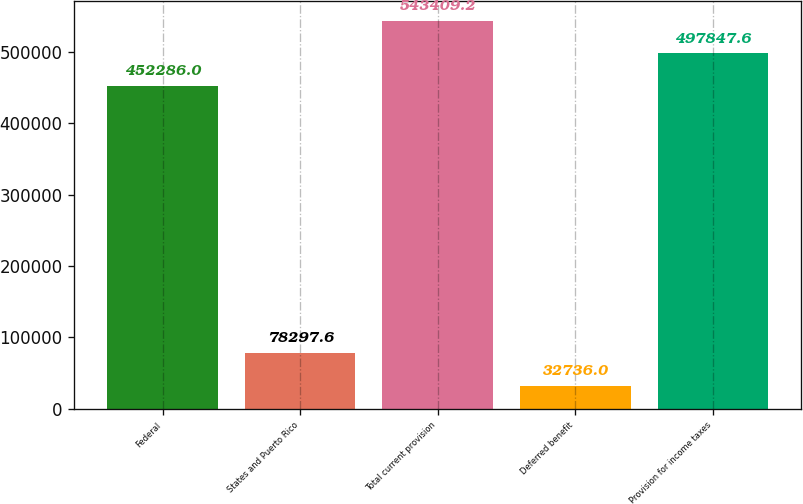Convert chart to OTSL. <chart><loc_0><loc_0><loc_500><loc_500><bar_chart><fcel>Federal<fcel>States and Puerto Rico<fcel>Total current provision<fcel>Deferred benefit<fcel>Provision for income taxes<nl><fcel>452286<fcel>78297.6<fcel>543409<fcel>32736<fcel>497848<nl></chart> 